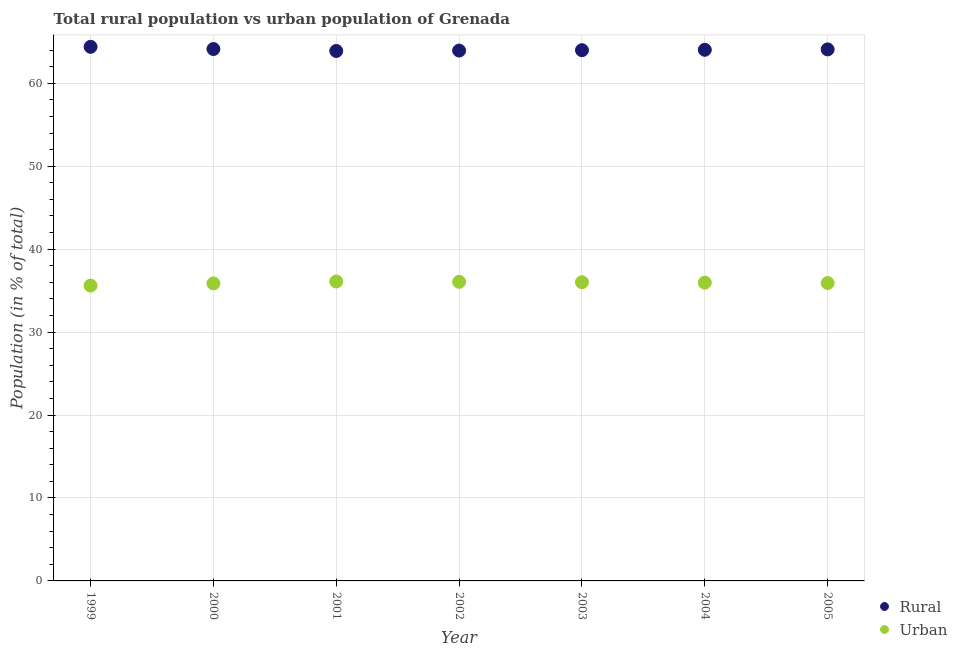How many different coloured dotlines are there?
Your answer should be very brief. 2. Is the number of dotlines equal to the number of legend labels?
Provide a succinct answer. Yes. What is the urban population in 2000?
Provide a succinct answer. 35.87. Across all years, what is the maximum urban population?
Your answer should be very brief. 36.1. Across all years, what is the minimum rural population?
Your response must be concise. 63.9. In which year was the urban population minimum?
Your answer should be compact. 1999. What is the total urban population in the graph?
Give a very brief answer. 251.53. What is the difference between the rural population in 2000 and that in 2005?
Give a very brief answer. 0.04. What is the difference between the urban population in 2001 and the rural population in 2000?
Offer a terse response. -28.02. What is the average rural population per year?
Make the answer very short. 64.07. In the year 2001, what is the difference between the rural population and urban population?
Offer a very short reply. 27.79. In how many years, is the urban population greater than 48 %?
Your answer should be very brief. 0. What is the ratio of the rural population in 2002 to that in 2005?
Your answer should be very brief. 1. What is the difference between the highest and the second highest rural population?
Offer a terse response. 0.27. What is the difference between the highest and the lowest urban population?
Your answer should be very brief. 0.5. In how many years, is the rural population greater than the average rural population taken over all years?
Your answer should be compact. 3. Is the sum of the urban population in 2000 and 2003 greater than the maximum rural population across all years?
Keep it short and to the point. Yes. Does the urban population monotonically increase over the years?
Your answer should be very brief. No. Is the urban population strictly greater than the rural population over the years?
Provide a short and direct response. No. Is the urban population strictly less than the rural population over the years?
Give a very brief answer. Yes. How many dotlines are there?
Offer a terse response. 2. How many years are there in the graph?
Offer a terse response. 7. What is the difference between two consecutive major ticks on the Y-axis?
Your answer should be very brief. 10. Where does the legend appear in the graph?
Keep it short and to the point. Bottom right. How many legend labels are there?
Give a very brief answer. 2. What is the title of the graph?
Give a very brief answer. Total rural population vs urban population of Grenada. What is the label or title of the Y-axis?
Your response must be concise. Population (in % of total). What is the Population (in % of total) in Rural in 1999?
Ensure brevity in your answer.  64.4. What is the Population (in % of total) in Urban in 1999?
Provide a short and direct response. 35.6. What is the Population (in % of total) in Rural in 2000?
Your answer should be very brief. 64.13. What is the Population (in % of total) in Urban in 2000?
Provide a succinct answer. 35.87. What is the Population (in % of total) in Rural in 2001?
Your response must be concise. 63.9. What is the Population (in % of total) of Urban in 2001?
Offer a very short reply. 36.1. What is the Population (in % of total) in Rural in 2002?
Give a very brief answer. 63.94. What is the Population (in % of total) of Urban in 2002?
Give a very brief answer. 36.06. What is the Population (in % of total) of Rural in 2003?
Your answer should be very brief. 63.99. What is the Population (in % of total) in Urban in 2003?
Offer a terse response. 36.01. What is the Population (in % of total) of Rural in 2004?
Offer a very short reply. 64.04. What is the Population (in % of total) of Urban in 2004?
Provide a short and direct response. 35.96. What is the Population (in % of total) in Rural in 2005?
Give a very brief answer. 64.08. What is the Population (in % of total) in Urban in 2005?
Your answer should be compact. 35.92. Across all years, what is the maximum Population (in % of total) in Rural?
Your answer should be compact. 64.4. Across all years, what is the maximum Population (in % of total) of Urban?
Your answer should be very brief. 36.1. Across all years, what is the minimum Population (in % of total) of Rural?
Give a very brief answer. 63.9. Across all years, what is the minimum Population (in % of total) of Urban?
Make the answer very short. 35.6. What is the total Population (in % of total) in Rural in the graph?
Your response must be concise. 448.47. What is the total Population (in % of total) in Urban in the graph?
Your answer should be compact. 251.53. What is the difference between the Population (in % of total) in Rural in 1999 and that in 2000?
Offer a very short reply. 0.27. What is the difference between the Population (in % of total) of Urban in 1999 and that in 2000?
Provide a succinct answer. -0.27. What is the difference between the Population (in % of total) in Rural in 1999 and that in 2001?
Offer a very short reply. 0.5. What is the difference between the Population (in % of total) of Urban in 1999 and that in 2001?
Your response must be concise. -0.5. What is the difference between the Population (in % of total) of Rural in 1999 and that in 2002?
Your answer should be compact. 0.45. What is the difference between the Population (in % of total) in Urban in 1999 and that in 2002?
Your answer should be compact. -0.45. What is the difference between the Population (in % of total) in Rural in 1999 and that in 2003?
Ensure brevity in your answer.  0.41. What is the difference between the Population (in % of total) of Urban in 1999 and that in 2003?
Provide a short and direct response. -0.41. What is the difference between the Population (in % of total) in Rural in 1999 and that in 2004?
Offer a very short reply. 0.36. What is the difference between the Population (in % of total) of Urban in 1999 and that in 2004?
Give a very brief answer. -0.36. What is the difference between the Population (in % of total) of Rural in 1999 and that in 2005?
Your answer should be very brief. 0.31. What is the difference between the Population (in % of total) in Urban in 1999 and that in 2005?
Give a very brief answer. -0.31. What is the difference between the Population (in % of total) in Rural in 2000 and that in 2001?
Offer a terse response. 0.23. What is the difference between the Population (in % of total) of Urban in 2000 and that in 2001?
Provide a succinct answer. -0.23. What is the difference between the Population (in % of total) of Rural in 2000 and that in 2002?
Your answer should be compact. 0.19. What is the difference between the Population (in % of total) of Urban in 2000 and that in 2002?
Your answer should be very brief. -0.19. What is the difference between the Population (in % of total) in Rural in 2000 and that in 2003?
Provide a short and direct response. 0.14. What is the difference between the Population (in % of total) in Urban in 2000 and that in 2003?
Ensure brevity in your answer.  -0.14. What is the difference between the Population (in % of total) of Rural in 2000 and that in 2004?
Ensure brevity in your answer.  0.09. What is the difference between the Population (in % of total) of Urban in 2000 and that in 2004?
Your response must be concise. -0.09. What is the difference between the Population (in % of total) in Rural in 2000 and that in 2005?
Provide a short and direct response. 0.04. What is the difference between the Population (in % of total) of Urban in 2000 and that in 2005?
Provide a short and direct response. -0.04. What is the difference between the Population (in % of total) of Rural in 2001 and that in 2002?
Keep it short and to the point. -0.05. What is the difference between the Population (in % of total) of Urban in 2001 and that in 2002?
Your answer should be very brief. 0.05. What is the difference between the Population (in % of total) of Rural in 2001 and that in 2003?
Your answer should be very brief. -0.09. What is the difference between the Population (in % of total) of Urban in 2001 and that in 2003?
Make the answer very short. 0.09. What is the difference between the Population (in % of total) of Rural in 2001 and that in 2004?
Your answer should be compact. -0.14. What is the difference between the Population (in % of total) of Urban in 2001 and that in 2004?
Ensure brevity in your answer.  0.14. What is the difference between the Population (in % of total) of Rural in 2001 and that in 2005?
Provide a short and direct response. -0.19. What is the difference between the Population (in % of total) of Urban in 2001 and that in 2005?
Your answer should be very brief. 0.19. What is the difference between the Population (in % of total) in Rural in 2002 and that in 2003?
Offer a very short reply. -0.05. What is the difference between the Population (in % of total) of Urban in 2002 and that in 2003?
Provide a succinct answer. 0.05. What is the difference between the Population (in % of total) of Rural in 2002 and that in 2004?
Offer a very short reply. -0.1. What is the difference between the Population (in % of total) in Urban in 2002 and that in 2004?
Keep it short and to the point. 0.1. What is the difference between the Population (in % of total) of Rural in 2002 and that in 2005?
Offer a very short reply. -0.14. What is the difference between the Population (in % of total) in Urban in 2002 and that in 2005?
Give a very brief answer. 0.14. What is the difference between the Population (in % of total) in Rural in 2003 and that in 2004?
Provide a short and direct response. -0.05. What is the difference between the Population (in % of total) in Urban in 2003 and that in 2004?
Offer a very short reply. 0.05. What is the difference between the Population (in % of total) in Rural in 2003 and that in 2005?
Offer a very short reply. -0.1. What is the difference between the Population (in % of total) in Urban in 2003 and that in 2005?
Offer a very short reply. 0.1. What is the difference between the Population (in % of total) in Rural in 2004 and that in 2005?
Your answer should be very brief. -0.05. What is the difference between the Population (in % of total) in Urban in 2004 and that in 2005?
Offer a very short reply. 0.05. What is the difference between the Population (in % of total) of Rural in 1999 and the Population (in % of total) of Urban in 2000?
Your answer should be very brief. 28.52. What is the difference between the Population (in % of total) of Rural in 1999 and the Population (in % of total) of Urban in 2001?
Give a very brief answer. 28.29. What is the difference between the Population (in % of total) in Rural in 1999 and the Population (in % of total) in Urban in 2002?
Provide a succinct answer. 28.34. What is the difference between the Population (in % of total) of Rural in 1999 and the Population (in % of total) of Urban in 2003?
Provide a short and direct response. 28.39. What is the difference between the Population (in % of total) of Rural in 1999 and the Population (in % of total) of Urban in 2004?
Ensure brevity in your answer.  28.43. What is the difference between the Population (in % of total) of Rural in 1999 and the Population (in % of total) of Urban in 2005?
Keep it short and to the point. 28.48. What is the difference between the Population (in % of total) in Rural in 2000 and the Population (in % of total) in Urban in 2001?
Offer a very short reply. 28.02. What is the difference between the Population (in % of total) of Rural in 2000 and the Population (in % of total) of Urban in 2002?
Keep it short and to the point. 28.07. What is the difference between the Population (in % of total) of Rural in 2000 and the Population (in % of total) of Urban in 2003?
Your answer should be compact. 28.12. What is the difference between the Population (in % of total) in Rural in 2000 and the Population (in % of total) in Urban in 2004?
Your answer should be compact. 28.17. What is the difference between the Population (in % of total) of Rural in 2000 and the Population (in % of total) of Urban in 2005?
Your answer should be very brief. 28.21. What is the difference between the Population (in % of total) of Rural in 2001 and the Population (in % of total) of Urban in 2002?
Make the answer very short. 27.84. What is the difference between the Population (in % of total) of Rural in 2001 and the Population (in % of total) of Urban in 2003?
Keep it short and to the point. 27.88. What is the difference between the Population (in % of total) in Rural in 2001 and the Population (in % of total) in Urban in 2004?
Your answer should be compact. 27.93. What is the difference between the Population (in % of total) in Rural in 2001 and the Population (in % of total) in Urban in 2005?
Make the answer very short. 27.98. What is the difference between the Population (in % of total) of Rural in 2002 and the Population (in % of total) of Urban in 2003?
Your answer should be very brief. 27.93. What is the difference between the Population (in % of total) in Rural in 2002 and the Population (in % of total) in Urban in 2004?
Give a very brief answer. 27.98. What is the difference between the Population (in % of total) of Rural in 2002 and the Population (in % of total) of Urban in 2005?
Ensure brevity in your answer.  28.03. What is the difference between the Population (in % of total) in Rural in 2003 and the Population (in % of total) in Urban in 2004?
Give a very brief answer. 28.03. What is the difference between the Population (in % of total) in Rural in 2003 and the Population (in % of total) in Urban in 2005?
Your answer should be compact. 28.07. What is the difference between the Population (in % of total) of Rural in 2004 and the Population (in % of total) of Urban in 2005?
Your response must be concise. 28.12. What is the average Population (in % of total) of Rural per year?
Keep it short and to the point. 64.07. What is the average Population (in % of total) of Urban per year?
Offer a very short reply. 35.93. In the year 1999, what is the difference between the Population (in % of total) of Rural and Population (in % of total) of Urban?
Offer a very short reply. 28.79. In the year 2000, what is the difference between the Population (in % of total) in Rural and Population (in % of total) in Urban?
Your response must be concise. 28.26. In the year 2001, what is the difference between the Population (in % of total) of Rural and Population (in % of total) of Urban?
Make the answer very short. 27.79. In the year 2002, what is the difference between the Population (in % of total) in Rural and Population (in % of total) in Urban?
Ensure brevity in your answer.  27.88. In the year 2003, what is the difference between the Population (in % of total) of Rural and Population (in % of total) of Urban?
Your answer should be very brief. 27.98. In the year 2004, what is the difference between the Population (in % of total) of Rural and Population (in % of total) of Urban?
Your response must be concise. 28.07. In the year 2005, what is the difference between the Population (in % of total) in Rural and Population (in % of total) in Urban?
Your answer should be compact. 28.17. What is the ratio of the Population (in % of total) in Rural in 1999 to that in 2001?
Keep it short and to the point. 1.01. What is the ratio of the Population (in % of total) of Urban in 1999 to that in 2001?
Offer a very short reply. 0.99. What is the ratio of the Population (in % of total) of Rural in 1999 to that in 2002?
Make the answer very short. 1.01. What is the ratio of the Population (in % of total) of Urban in 1999 to that in 2002?
Ensure brevity in your answer.  0.99. What is the ratio of the Population (in % of total) in Rural in 1999 to that in 2003?
Offer a terse response. 1.01. What is the ratio of the Population (in % of total) in Urban in 1999 to that in 2003?
Make the answer very short. 0.99. What is the ratio of the Population (in % of total) in Rural in 1999 to that in 2004?
Offer a terse response. 1.01. What is the ratio of the Population (in % of total) of Urban in 1999 to that in 2005?
Make the answer very short. 0.99. What is the ratio of the Population (in % of total) in Rural in 2000 to that in 2001?
Your response must be concise. 1. What is the ratio of the Population (in % of total) in Urban in 2000 to that in 2001?
Your answer should be very brief. 0.99. What is the ratio of the Population (in % of total) in Rural in 2000 to that in 2002?
Provide a succinct answer. 1. What is the ratio of the Population (in % of total) of Urban in 2000 to that in 2002?
Your answer should be very brief. 0.99. What is the ratio of the Population (in % of total) in Rural in 2000 to that in 2003?
Your answer should be very brief. 1. What is the ratio of the Population (in % of total) in Urban in 2000 to that in 2003?
Provide a succinct answer. 1. What is the ratio of the Population (in % of total) of Rural in 2000 to that in 2004?
Your answer should be compact. 1. What is the ratio of the Population (in % of total) of Urban in 2000 to that in 2004?
Make the answer very short. 1. What is the ratio of the Population (in % of total) in Rural in 2001 to that in 2002?
Your answer should be compact. 1. What is the ratio of the Population (in % of total) of Urban in 2001 to that in 2002?
Provide a succinct answer. 1. What is the ratio of the Population (in % of total) in Rural in 2001 to that in 2003?
Your answer should be compact. 1. What is the ratio of the Population (in % of total) of Urban in 2001 to that in 2004?
Offer a very short reply. 1. What is the ratio of the Population (in % of total) of Rural in 2001 to that in 2005?
Ensure brevity in your answer.  1. What is the ratio of the Population (in % of total) of Urban in 2001 to that in 2005?
Keep it short and to the point. 1.01. What is the ratio of the Population (in % of total) of Rural in 2002 to that in 2003?
Make the answer very short. 1. What is the ratio of the Population (in % of total) in Urban in 2002 to that in 2003?
Give a very brief answer. 1. What is the ratio of the Population (in % of total) in Urban in 2002 to that in 2004?
Provide a succinct answer. 1. What is the ratio of the Population (in % of total) in Rural in 2002 to that in 2005?
Provide a succinct answer. 1. What is the ratio of the Population (in % of total) in Urban in 2002 to that in 2005?
Provide a short and direct response. 1. What is the ratio of the Population (in % of total) in Rural in 2003 to that in 2004?
Your response must be concise. 1. What is the ratio of the Population (in % of total) in Urban in 2003 to that in 2004?
Offer a terse response. 1. What is the ratio of the Population (in % of total) in Urban in 2003 to that in 2005?
Your answer should be compact. 1. What is the ratio of the Population (in % of total) of Rural in 2004 to that in 2005?
Make the answer very short. 1. What is the ratio of the Population (in % of total) in Urban in 2004 to that in 2005?
Offer a terse response. 1. What is the difference between the highest and the second highest Population (in % of total) in Rural?
Ensure brevity in your answer.  0.27. What is the difference between the highest and the second highest Population (in % of total) in Urban?
Provide a succinct answer. 0.05. What is the difference between the highest and the lowest Population (in % of total) in Rural?
Make the answer very short. 0.5. What is the difference between the highest and the lowest Population (in % of total) in Urban?
Give a very brief answer. 0.5. 